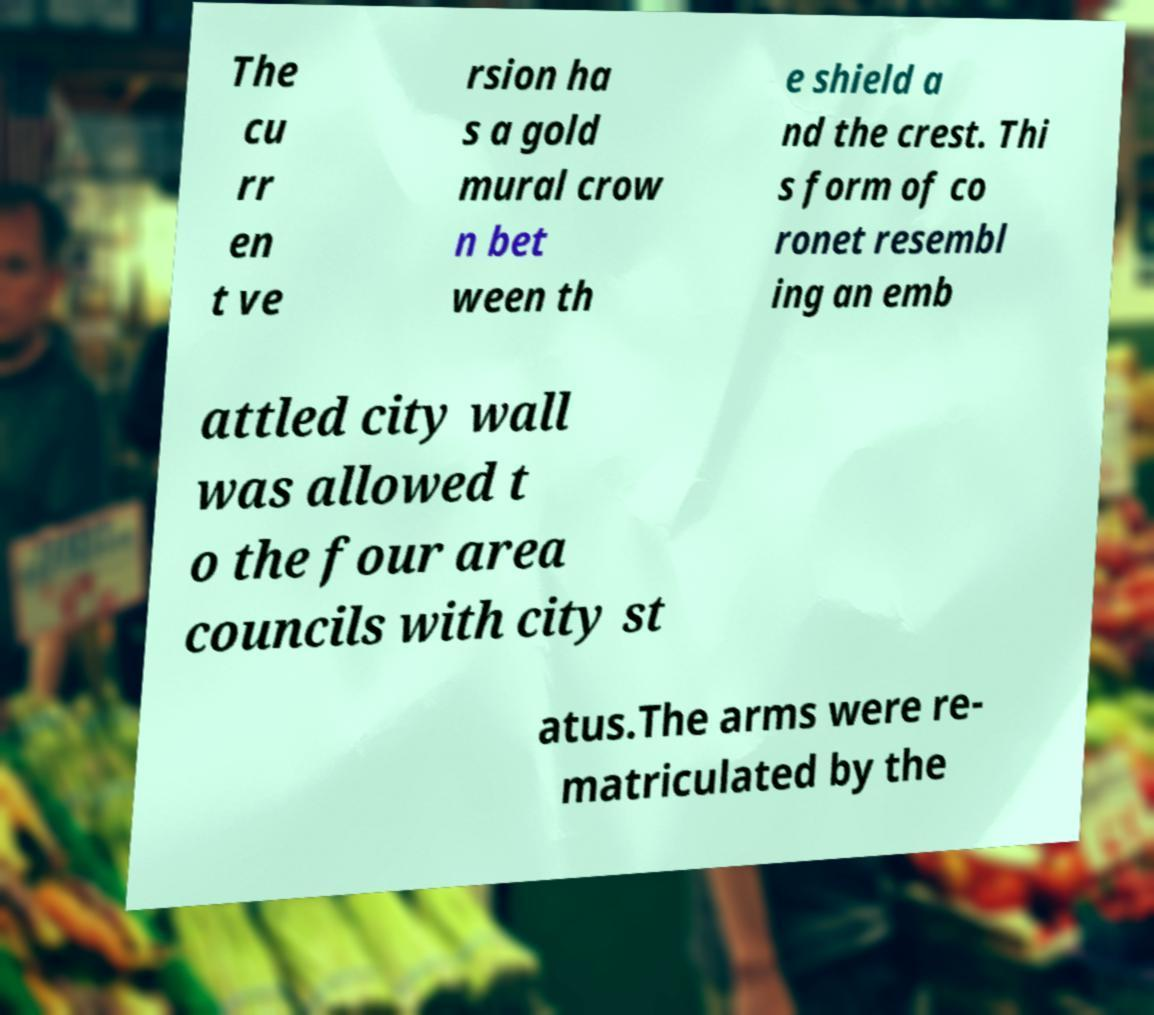I need the written content from this picture converted into text. Can you do that? The cu rr en t ve rsion ha s a gold mural crow n bet ween th e shield a nd the crest. Thi s form of co ronet resembl ing an emb attled city wall was allowed t o the four area councils with city st atus.The arms were re- matriculated by the 